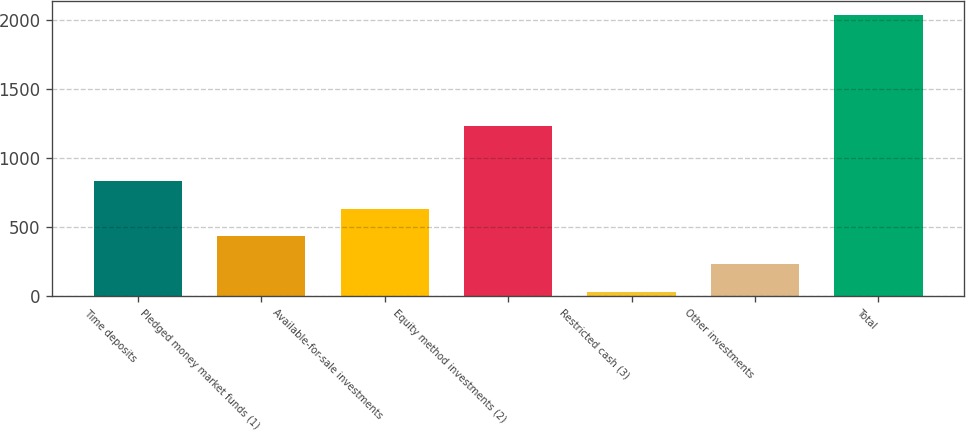Convert chart to OTSL. <chart><loc_0><loc_0><loc_500><loc_500><bar_chart><fcel>Time deposits<fcel>Pledged money market funds (1)<fcel>Available-for-sale investments<fcel>Equity method investments (2)<fcel>Restricted cash (3)<fcel>Other investments<fcel>Total<nl><fcel>832.2<fcel>431.6<fcel>631.9<fcel>1230<fcel>31<fcel>231.3<fcel>2034<nl></chart> 